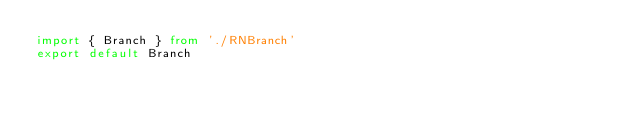Convert code to text. <code><loc_0><loc_0><loc_500><loc_500><_TypeScript_>import { Branch } from './RNBranch'
export default Branch
</code> 